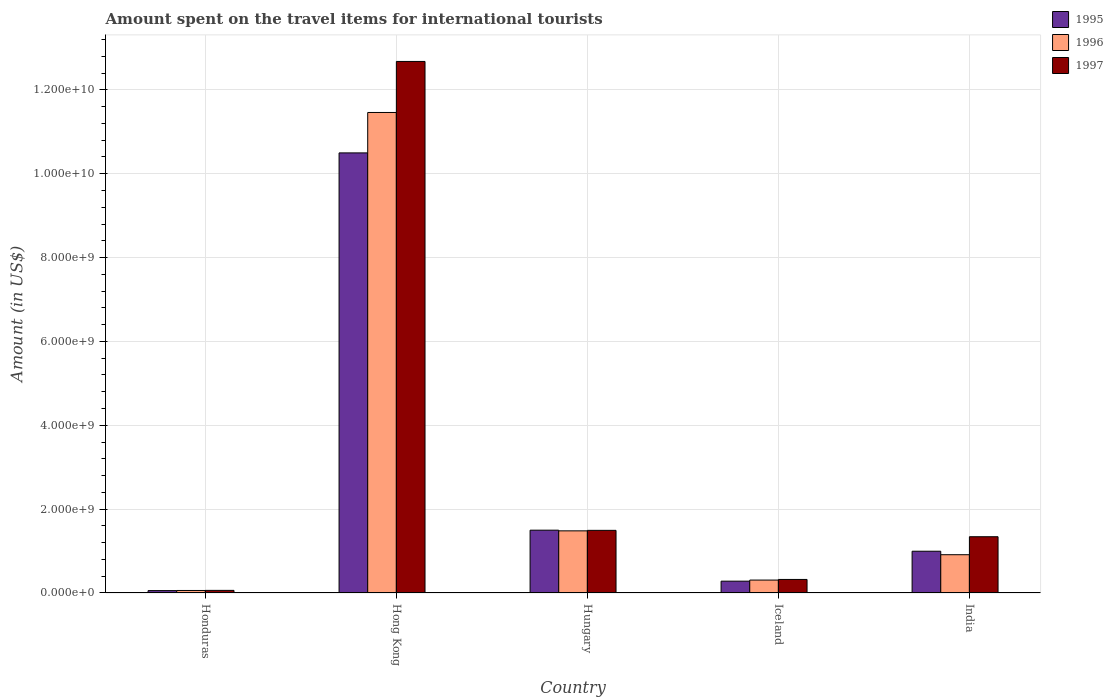How many different coloured bars are there?
Provide a short and direct response. 3. How many bars are there on the 5th tick from the right?
Offer a very short reply. 3. What is the label of the 3rd group of bars from the left?
Your answer should be very brief. Hungary. In how many cases, is the number of bars for a given country not equal to the number of legend labels?
Make the answer very short. 0. What is the amount spent on the travel items for international tourists in 1996 in Hong Kong?
Your answer should be very brief. 1.15e+1. Across all countries, what is the maximum amount spent on the travel items for international tourists in 1995?
Offer a terse response. 1.05e+1. Across all countries, what is the minimum amount spent on the travel items for international tourists in 1995?
Offer a terse response. 5.70e+07. In which country was the amount spent on the travel items for international tourists in 1995 maximum?
Your answer should be very brief. Hong Kong. In which country was the amount spent on the travel items for international tourists in 1996 minimum?
Offer a terse response. Honduras. What is the total amount spent on the travel items for international tourists in 1997 in the graph?
Your response must be concise. 1.59e+1. What is the difference between the amount spent on the travel items for international tourists in 1996 in Honduras and that in Hungary?
Offer a terse response. -1.42e+09. What is the difference between the amount spent on the travel items for international tourists in 1995 in Iceland and the amount spent on the travel items for international tourists in 1997 in Hong Kong?
Your answer should be compact. -1.24e+1. What is the average amount spent on the travel items for international tourists in 1996 per country?
Provide a short and direct response. 2.84e+09. What is the difference between the amount spent on the travel items for international tourists of/in 1997 and amount spent on the travel items for international tourists of/in 1996 in India?
Offer a terse response. 4.29e+08. In how many countries, is the amount spent on the travel items for international tourists in 1997 greater than 1600000000 US$?
Keep it short and to the point. 1. What is the ratio of the amount spent on the travel items for international tourists in 1997 in Hong Kong to that in Hungary?
Give a very brief answer. 8.49. Is the difference between the amount spent on the travel items for international tourists in 1997 in Iceland and India greater than the difference between the amount spent on the travel items for international tourists in 1996 in Iceland and India?
Provide a succinct answer. No. What is the difference between the highest and the second highest amount spent on the travel items for international tourists in 1997?
Keep it short and to the point. 1.13e+1. What is the difference between the highest and the lowest amount spent on the travel items for international tourists in 1995?
Make the answer very short. 1.04e+1. What does the 3rd bar from the left in India represents?
Your response must be concise. 1997. How many bars are there?
Give a very brief answer. 15. How many countries are there in the graph?
Your response must be concise. 5. Are the values on the major ticks of Y-axis written in scientific E-notation?
Your answer should be compact. Yes. Does the graph contain grids?
Offer a very short reply. Yes. How many legend labels are there?
Keep it short and to the point. 3. What is the title of the graph?
Give a very brief answer. Amount spent on the travel items for international tourists. What is the label or title of the Y-axis?
Keep it short and to the point. Amount (in US$). What is the Amount (in US$) of 1995 in Honduras?
Your answer should be very brief. 5.70e+07. What is the Amount (in US$) in 1996 in Honduras?
Give a very brief answer. 6.00e+07. What is the Amount (in US$) of 1997 in Honduras?
Offer a terse response. 6.20e+07. What is the Amount (in US$) of 1995 in Hong Kong?
Offer a terse response. 1.05e+1. What is the Amount (in US$) of 1996 in Hong Kong?
Provide a short and direct response. 1.15e+1. What is the Amount (in US$) in 1997 in Hong Kong?
Offer a very short reply. 1.27e+1. What is the Amount (in US$) of 1995 in Hungary?
Provide a short and direct response. 1.50e+09. What is the Amount (in US$) of 1996 in Hungary?
Keep it short and to the point. 1.48e+09. What is the Amount (in US$) of 1997 in Hungary?
Make the answer very short. 1.49e+09. What is the Amount (in US$) of 1995 in Iceland?
Give a very brief answer. 2.82e+08. What is the Amount (in US$) in 1996 in Iceland?
Offer a very short reply. 3.08e+08. What is the Amount (in US$) of 1997 in Iceland?
Provide a short and direct response. 3.23e+08. What is the Amount (in US$) in 1995 in India?
Offer a very short reply. 9.96e+08. What is the Amount (in US$) of 1996 in India?
Your response must be concise. 9.13e+08. What is the Amount (in US$) of 1997 in India?
Your answer should be very brief. 1.34e+09. Across all countries, what is the maximum Amount (in US$) in 1995?
Keep it short and to the point. 1.05e+1. Across all countries, what is the maximum Amount (in US$) of 1996?
Provide a short and direct response. 1.15e+1. Across all countries, what is the maximum Amount (in US$) of 1997?
Your response must be concise. 1.27e+1. Across all countries, what is the minimum Amount (in US$) in 1995?
Offer a very short reply. 5.70e+07. Across all countries, what is the minimum Amount (in US$) of 1996?
Give a very brief answer. 6.00e+07. Across all countries, what is the minimum Amount (in US$) in 1997?
Your answer should be compact. 6.20e+07. What is the total Amount (in US$) in 1995 in the graph?
Your response must be concise. 1.33e+1. What is the total Amount (in US$) of 1996 in the graph?
Make the answer very short. 1.42e+1. What is the total Amount (in US$) of 1997 in the graph?
Keep it short and to the point. 1.59e+1. What is the difference between the Amount (in US$) in 1995 in Honduras and that in Hong Kong?
Ensure brevity in your answer.  -1.04e+1. What is the difference between the Amount (in US$) of 1996 in Honduras and that in Hong Kong?
Offer a very short reply. -1.14e+1. What is the difference between the Amount (in US$) in 1997 in Honduras and that in Hong Kong?
Your response must be concise. -1.26e+1. What is the difference between the Amount (in US$) in 1995 in Honduras and that in Hungary?
Your answer should be very brief. -1.44e+09. What is the difference between the Amount (in US$) of 1996 in Honduras and that in Hungary?
Offer a terse response. -1.42e+09. What is the difference between the Amount (in US$) of 1997 in Honduras and that in Hungary?
Offer a terse response. -1.43e+09. What is the difference between the Amount (in US$) of 1995 in Honduras and that in Iceland?
Give a very brief answer. -2.25e+08. What is the difference between the Amount (in US$) in 1996 in Honduras and that in Iceland?
Give a very brief answer. -2.48e+08. What is the difference between the Amount (in US$) in 1997 in Honduras and that in Iceland?
Give a very brief answer. -2.61e+08. What is the difference between the Amount (in US$) in 1995 in Honduras and that in India?
Provide a succinct answer. -9.39e+08. What is the difference between the Amount (in US$) of 1996 in Honduras and that in India?
Provide a short and direct response. -8.53e+08. What is the difference between the Amount (in US$) of 1997 in Honduras and that in India?
Your answer should be compact. -1.28e+09. What is the difference between the Amount (in US$) in 1995 in Hong Kong and that in Hungary?
Keep it short and to the point. 9.00e+09. What is the difference between the Amount (in US$) in 1996 in Hong Kong and that in Hungary?
Your answer should be very brief. 9.98e+09. What is the difference between the Amount (in US$) of 1997 in Hong Kong and that in Hungary?
Your response must be concise. 1.12e+1. What is the difference between the Amount (in US$) in 1995 in Hong Kong and that in Iceland?
Your answer should be compact. 1.02e+1. What is the difference between the Amount (in US$) in 1996 in Hong Kong and that in Iceland?
Your answer should be very brief. 1.12e+1. What is the difference between the Amount (in US$) of 1997 in Hong Kong and that in Iceland?
Keep it short and to the point. 1.24e+1. What is the difference between the Amount (in US$) in 1995 in Hong Kong and that in India?
Provide a succinct answer. 9.50e+09. What is the difference between the Amount (in US$) of 1996 in Hong Kong and that in India?
Keep it short and to the point. 1.05e+1. What is the difference between the Amount (in US$) of 1997 in Hong Kong and that in India?
Ensure brevity in your answer.  1.13e+1. What is the difference between the Amount (in US$) in 1995 in Hungary and that in Iceland?
Offer a very short reply. 1.22e+09. What is the difference between the Amount (in US$) in 1996 in Hungary and that in Iceland?
Provide a succinct answer. 1.17e+09. What is the difference between the Amount (in US$) of 1997 in Hungary and that in Iceland?
Your response must be concise. 1.17e+09. What is the difference between the Amount (in US$) of 1995 in Hungary and that in India?
Give a very brief answer. 5.02e+08. What is the difference between the Amount (in US$) of 1996 in Hungary and that in India?
Your answer should be compact. 5.69e+08. What is the difference between the Amount (in US$) in 1997 in Hungary and that in India?
Keep it short and to the point. 1.52e+08. What is the difference between the Amount (in US$) in 1995 in Iceland and that in India?
Provide a succinct answer. -7.14e+08. What is the difference between the Amount (in US$) of 1996 in Iceland and that in India?
Provide a succinct answer. -6.05e+08. What is the difference between the Amount (in US$) in 1997 in Iceland and that in India?
Your answer should be compact. -1.02e+09. What is the difference between the Amount (in US$) in 1995 in Honduras and the Amount (in US$) in 1996 in Hong Kong?
Offer a very short reply. -1.14e+1. What is the difference between the Amount (in US$) of 1995 in Honduras and the Amount (in US$) of 1997 in Hong Kong?
Your response must be concise. -1.26e+1. What is the difference between the Amount (in US$) in 1996 in Honduras and the Amount (in US$) in 1997 in Hong Kong?
Your answer should be very brief. -1.26e+1. What is the difference between the Amount (in US$) of 1995 in Honduras and the Amount (in US$) of 1996 in Hungary?
Your answer should be very brief. -1.42e+09. What is the difference between the Amount (in US$) in 1995 in Honduras and the Amount (in US$) in 1997 in Hungary?
Ensure brevity in your answer.  -1.44e+09. What is the difference between the Amount (in US$) in 1996 in Honduras and the Amount (in US$) in 1997 in Hungary?
Offer a terse response. -1.43e+09. What is the difference between the Amount (in US$) in 1995 in Honduras and the Amount (in US$) in 1996 in Iceland?
Your response must be concise. -2.51e+08. What is the difference between the Amount (in US$) in 1995 in Honduras and the Amount (in US$) in 1997 in Iceland?
Provide a succinct answer. -2.66e+08. What is the difference between the Amount (in US$) in 1996 in Honduras and the Amount (in US$) in 1997 in Iceland?
Offer a terse response. -2.63e+08. What is the difference between the Amount (in US$) in 1995 in Honduras and the Amount (in US$) in 1996 in India?
Make the answer very short. -8.56e+08. What is the difference between the Amount (in US$) of 1995 in Honduras and the Amount (in US$) of 1997 in India?
Your answer should be compact. -1.28e+09. What is the difference between the Amount (in US$) of 1996 in Honduras and the Amount (in US$) of 1997 in India?
Ensure brevity in your answer.  -1.28e+09. What is the difference between the Amount (in US$) of 1995 in Hong Kong and the Amount (in US$) of 1996 in Hungary?
Provide a short and direct response. 9.02e+09. What is the difference between the Amount (in US$) of 1995 in Hong Kong and the Amount (in US$) of 1997 in Hungary?
Ensure brevity in your answer.  9.00e+09. What is the difference between the Amount (in US$) of 1996 in Hong Kong and the Amount (in US$) of 1997 in Hungary?
Keep it short and to the point. 9.97e+09. What is the difference between the Amount (in US$) of 1995 in Hong Kong and the Amount (in US$) of 1996 in Iceland?
Provide a succinct answer. 1.02e+1. What is the difference between the Amount (in US$) of 1995 in Hong Kong and the Amount (in US$) of 1997 in Iceland?
Offer a very short reply. 1.02e+1. What is the difference between the Amount (in US$) of 1996 in Hong Kong and the Amount (in US$) of 1997 in Iceland?
Ensure brevity in your answer.  1.11e+1. What is the difference between the Amount (in US$) of 1995 in Hong Kong and the Amount (in US$) of 1996 in India?
Provide a succinct answer. 9.58e+09. What is the difference between the Amount (in US$) of 1995 in Hong Kong and the Amount (in US$) of 1997 in India?
Give a very brief answer. 9.16e+09. What is the difference between the Amount (in US$) in 1996 in Hong Kong and the Amount (in US$) in 1997 in India?
Make the answer very short. 1.01e+1. What is the difference between the Amount (in US$) in 1995 in Hungary and the Amount (in US$) in 1996 in Iceland?
Offer a very short reply. 1.19e+09. What is the difference between the Amount (in US$) of 1995 in Hungary and the Amount (in US$) of 1997 in Iceland?
Make the answer very short. 1.18e+09. What is the difference between the Amount (in US$) of 1996 in Hungary and the Amount (in US$) of 1997 in Iceland?
Your answer should be very brief. 1.16e+09. What is the difference between the Amount (in US$) in 1995 in Hungary and the Amount (in US$) in 1996 in India?
Provide a short and direct response. 5.85e+08. What is the difference between the Amount (in US$) in 1995 in Hungary and the Amount (in US$) in 1997 in India?
Your answer should be compact. 1.56e+08. What is the difference between the Amount (in US$) in 1996 in Hungary and the Amount (in US$) in 1997 in India?
Your answer should be compact. 1.40e+08. What is the difference between the Amount (in US$) in 1995 in Iceland and the Amount (in US$) in 1996 in India?
Your response must be concise. -6.31e+08. What is the difference between the Amount (in US$) of 1995 in Iceland and the Amount (in US$) of 1997 in India?
Provide a succinct answer. -1.06e+09. What is the difference between the Amount (in US$) of 1996 in Iceland and the Amount (in US$) of 1997 in India?
Your answer should be very brief. -1.03e+09. What is the average Amount (in US$) in 1995 per country?
Give a very brief answer. 2.67e+09. What is the average Amount (in US$) in 1996 per country?
Offer a terse response. 2.84e+09. What is the average Amount (in US$) in 1997 per country?
Offer a very short reply. 3.18e+09. What is the difference between the Amount (in US$) in 1995 and Amount (in US$) in 1996 in Honduras?
Offer a terse response. -3.00e+06. What is the difference between the Amount (in US$) of 1995 and Amount (in US$) of 1997 in Honduras?
Provide a short and direct response. -5.00e+06. What is the difference between the Amount (in US$) in 1996 and Amount (in US$) in 1997 in Honduras?
Ensure brevity in your answer.  -2.00e+06. What is the difference between the Amount (in US$) of 1995 and Amount (in US$) of 1996 in Hong Kong?
Ensure brevity in your answer.  -9.64e+08. What is the difference between the Amount (in US$) in 1995 and Amount (in US$) in 1997 in Hong Kong?
Ensure brevity in your answer.  -2.18e+09. What is the difference between the Amount (in US$) of 1996 and Amount (in US$) of 1997 in Hong Kong?
Provide a short and direct response. -1.22e+09. What is the difference between the Amount (in US$) in 1995 and Amount (in US$) in 1996 in Hungary?
Provide a short and direct response. 1.60e+07. What is the difference between the Amount (in US$) in 1996 and Amount (in US$) in 1997 in Hungary?
Offer a very short reply. -1.20e+07. What is the difference between the Amount (in US$) in 1995 and Amount (in US$) in 1996 in Iceland?
Provide a short and direct response. -2.60e+07. What is the difference between the Amount (in US$) of 1995 and Amount (in US$) of 1997 in Iceland?
Your response must be concise. -4.10e+07. What is the difference between the Amount (in US$) of 1996 and Amount (in US$) of 1997 in Iceland?
Keep it short and to the point. -1.50e+07. What is the difference between the Amount (in US$) in 1995 and Amount (in US$) in 1996 in India?
Offer a terse response. 8.30e+07. What is the difference between the Amount (in US$) in 1995 and Amount (in US$) in 1997 in India?
Make the answer very short. -3.46e+08. What is the difference between the Amount (in US$) in 1996 and Amount (in US$) in 1997 in India?
Offer a very short reply. -4.29e+08. What is the ratio of the Amount (in US$) of 1995 in Honduras to that in Hong Kong?
Your response must be concise. 0.01. What is the ratio of the Amount (in US$) of 1996 in Honduras to that in Hong Kong?
Keep it short and to the point. 0.01. What is the ratio of the Amount (in US$) of 1997 in Honduras to that in Hong Kong?
Make the answer very short. 0. What is the ratio of the Amount (in US$) in 1995 in Honduras to that in Hungary?
Offer a terse response. 0.04. What is the ratio of the Amount (in US$) of 1996 in Honduras to that in Hungary?
Provide a succinct answer. 0.04. What is the ratio of the Amount (in US$) of 1997 in Honduras to that in Hungary?
Offer a terse response. 0.04. What is the ratio of the Amount (in US$) of 1995 in Honduras to that in Iceland?
Your response must be concise. 0.2. What is the ratio of the Amount (in US$) of 1996 in Honduras to that in Iceland?
Your answer should be very brief. 0.19. What is the ratio of the Amount (in US$) in 1997 in Honduras to that in Iceland?
Ensure brevity in your answer.  0.19. What is the ratio of the Amount (in US$) in 1995 in Honduras to that in India?
Your response must be concise. 0.06. What is the ratio of the Amount (in US$) of 1996 in Honduras to that in India?
Offer a terse response. 0.07. What is the ratio of the Amount (in US$) in 1997 in Honduras to that in India?
Keep it short and to the point. 0.05. What is the ratio of the Amount (in US$) in 1995 in Hong Kong to that in Hungary?
Your answer should be very brief. 7.01. What is the ratio of the Amount (in US$) of 1996 in Hong Kong to that in Hungary?
Your answer should be compact. 7.73. What is the ratio of the Amount (in US$) in 1997 in Hong Kong to that in Hungary?
Ensure brevity in your answer.  8.49. What is the ratio of the Amount (in US$) of 1995 in Hong Kong to that in Iceland?
Make the answer very short. 37.22. What is the ratio of the Amount (in US$) in 1996 in Hong Kong to that in Iceland?
Provide a succinct answer. 37.21. What is the ratio of the Amount (in US$) of 1997 in Hong Kong to that in Iceland?
Your response must be concise. 39.25. What is the ratio of the Amount (in US$) of 1995 in Hong Kong to that in India?
Offer a very short reply. 10.54. What is the ratio of the Amount (in US$) in 1996 in Hong Kong to that in India?
Offer a terse response. 12.55. What is the ratio of the Amount (in US$) of 1997 in Hong Kong to that in India?
Offer a terse response. 9.45. What is the ratio of the Amount (in US$) of 1995 in Hungary to that in Iceland?
Your answer should be compact. 5.31. What is the ratio of the Amount (in US$) in 1996 in Hungary to that in Iceland?
Your answer should be very brief. 4.81. What is the ratio of the Amount (in US$) in 1997 in Hungary to that in Iceland?
Your answer should be very brief. 4.63. What is the ratio of the Amount (in US$) of 1995 in Hungary to that in India?
Your response must be concise. 1.5. What is the ratio of the Amount (in US$) of 1996 in Hungary to that in India?
Keep it short and to the point. 1.62. What is the ratio of the Amount (in US$) of 1997 in Hungary to that in India?
Keep it short and to the point. 1.11. What is the ratio of the Amount (in US$) of 1995 in Iceland to that in India?
Make the answer very short. 0.28. What is the ratio of the Amount (in US$) in 1996 in Iceland to that in India?
Make the answer very short. 0.34. What is the ratio of the Amount (in US$) in 1997 in Iceland to that in India?
Your answer should be very brief. 0.24. What is the difference between the highest and the second highest Amount (in US$) of 1995?
Make the answer very short. 9.00e+09. What is the difference between the highest and the second highest Amount (in US$) of 1996?
Your answer should be compact. 9.98e+09. What is the difference between the highest and the second highest Amount (in US$) in 1997?
Offer a very short reply. 1.12e+1. What is the difference between the highest and the lowest Amount (in US$) in 1995?
Ensure brevity in your answer.  1.04e+1. What is the difference between the highest and the lowest Amount (in US$) in 1996?
Your response must be concise. 1.14e+1. What is the difference between the highest and the lowest Amount (in US$) in 1997?
Offer a terse response. 1.26e+1. 